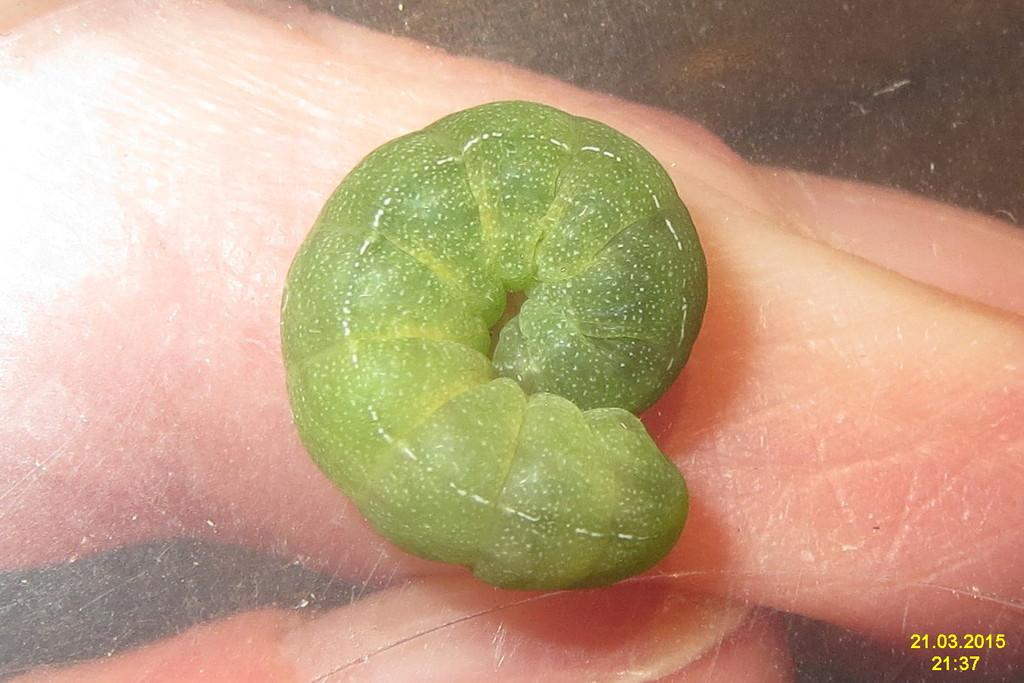What can be seen on the person's hand in the image? There is a green worm on the hand. Can you describe the appearance of the worm? The worm is green in color. Is there any additional information provided in the image? Yes, there is a time and date displayed in the bottom right corner of the image. What type of soup is being served in the image? There is no soup present in the image; it features a person's hand with a green worm on it. Can you describe the battle taking place in the image? There is no battle depicted in the image; it only shows a person's hand with a green worm on it and a time and date displayed in the bottom right corner. 